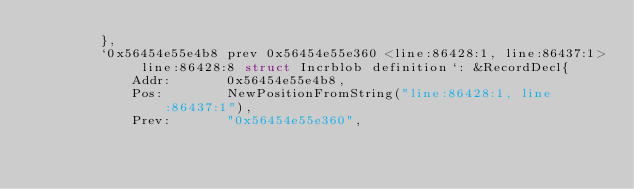<code> <loc_0><loc_0><loc_500><loc_500><_Go_>		},
		`0x56454e55e4b8 prev 0x56454e55e360 <line:86428:1, line:86437:1> line:86428:8 struct Incrblob definition`: &RecordDecl{
			Addr:       0x56454e55e4b8,
			Pos:        NewPositionFromString("line:86428:1, line:86437:1"),
			Prev:       "0x56454e55e360",</code> 